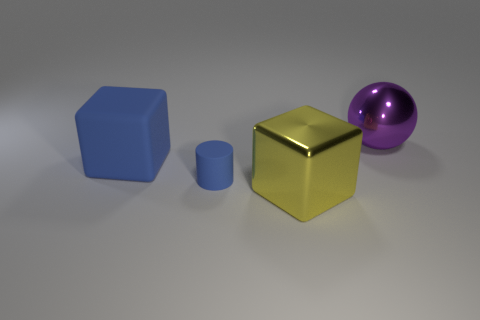How many other objects are the same shape as the large blue object? 1 